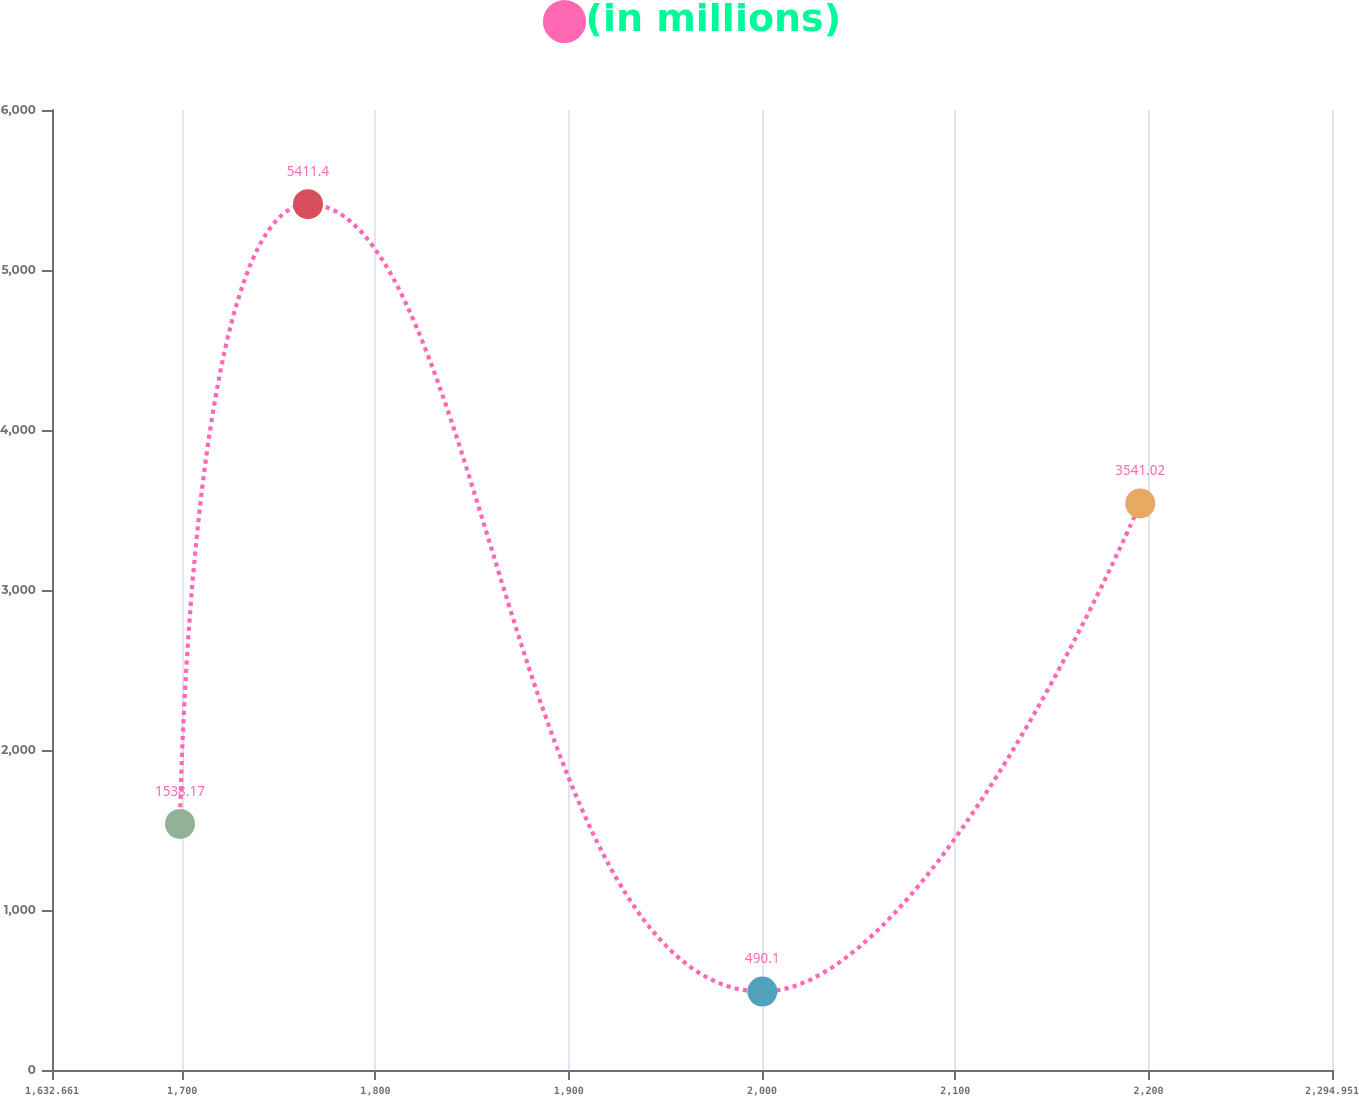Convert chart to OTSL. <chart><loc_0><loc_0><loc_500><loc_500><line_chart><ecel><fcel>(in millions)<nl><fcel>1698.89<fcel>1538.17<nl><fcel>1765.12<fcel>5411.4<nl><fcel>2000.23<fcel>490.1<nl><fcel>2195.75<fcel>3541.02<nl><fcel>2361.18<fcel>1046.04<nl></chart> 